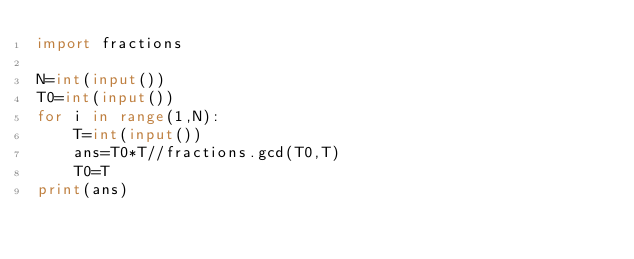<code> <loc_0><loc_0><loc_500><loc_500><_Python_>import fractions

N=int(input())
T0=int(input())
for i in range(1,N):
    T=int(input())
    ans=T0*T//fractions.gcd(T0,T)
    T0=T
print(ans)</code> 